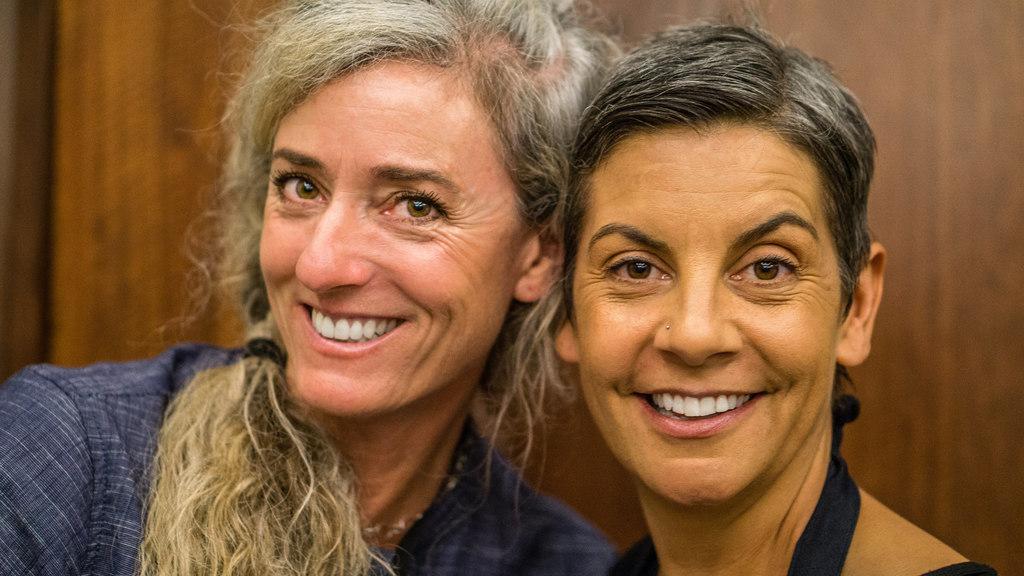Please provide a concise description of this image. In this image we can see women smiling. 